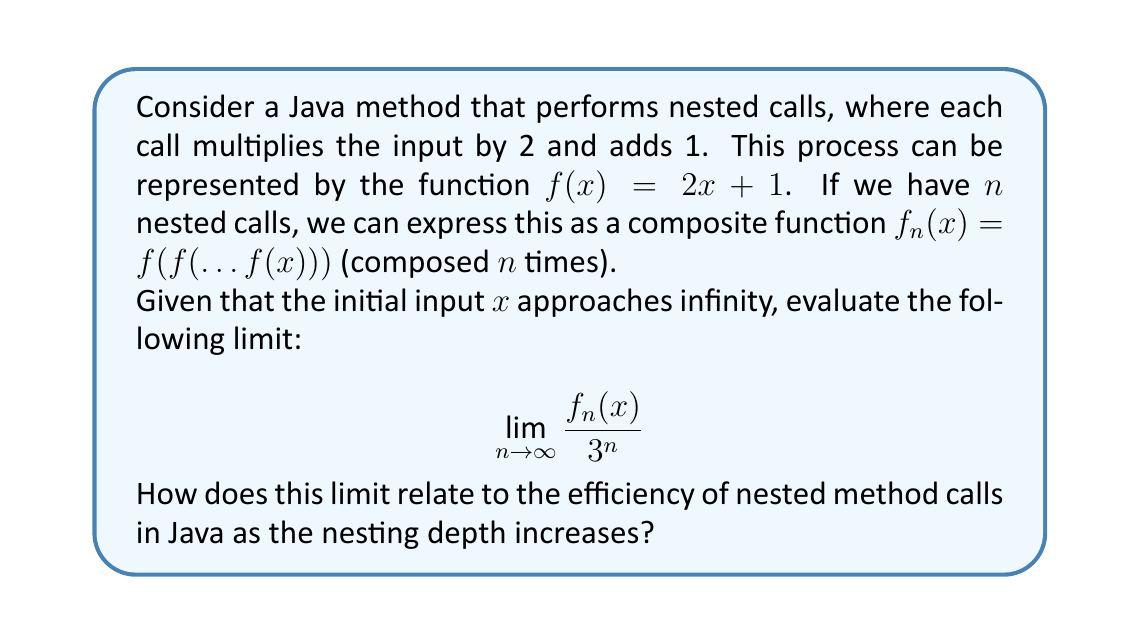Could you help me with this problem? Let's approach this step-by-step:

1) First, let's understand what $f_n(x)$ looks like for increasing values of $n$:
   $f_1(x) = 2x + 1$
   $f_2(x) = 2(2x + 1) + 1 = 4x + 3$
   $f_3(x) = 2(4x + 3) + 1 = 8x + 7$

2) We can observe a pattern forming:
   $f_n(x) = 2^n x + (2^n - 1)$

3) Now, let's substitute this into our limit:

   $$\lim_{n \to \infty} \frac{f_n(x)}{3^n} = \lim_{n \to \infty} \frac{2^n x + (2^n - 1)}{3^n}$$

4) We can separate this fraction:

   $$\lim_{n \to \infty} \left(\frac{2^n x}{3^n} + \frac{2^n - 1}{3^n}\right)$$

5) Simplify:

   $$\lim_{n \to \infty} \left(x \cdot \left(\frac{2}{3}\right)^n + \left(\frac{2}{3}\right)^n - \frac{1}{3^n}\right)$$

6) As $n$ approaches infinity, $\left(\frac{2}{3}\right)^n$ and $\frac{1}{3^n}$ both approach 0, regardless of the value of $x$.

7) Therefore, the limit evaluates to 0.

This result indicates that as the number of nested method calls (represented by $n$) increases to infinity, the growth rate of the function value is slower than $3^n$. In the context of Java programming, this suggests that the time complexity of such nested calls would be less than exponential with base 3, but still grows rapidly, potentially leading to performance issues for large $n$.
Answer: 0 